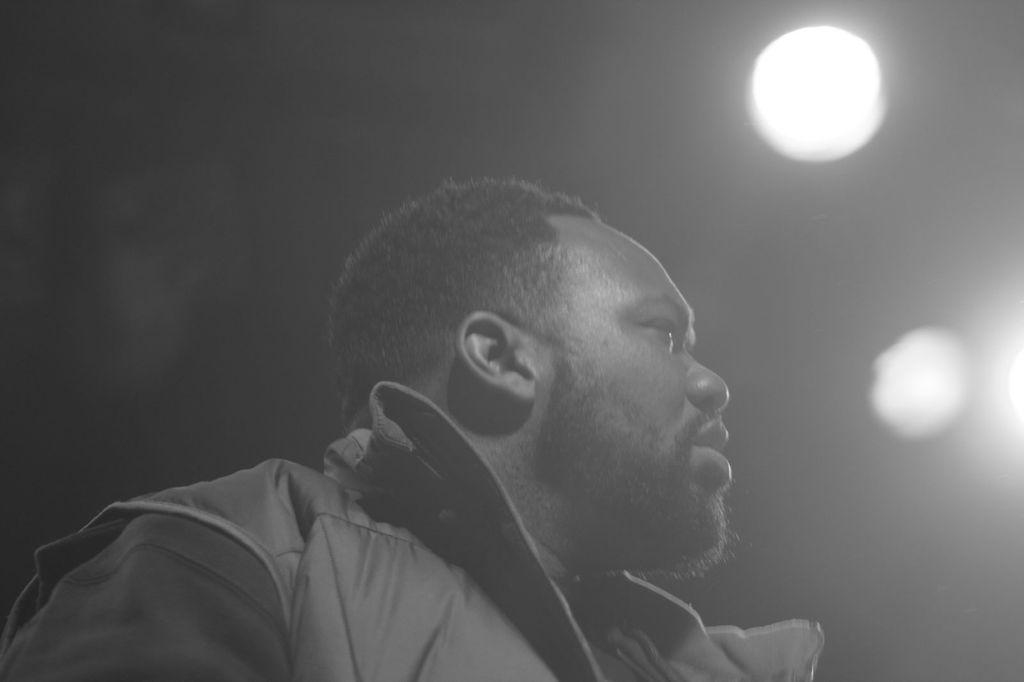What is the color scheme of the image? The image is black and white. Can you describe the main subject in the image? There is a person in the image. What can be seen in the background of the image? There are lights in the background of the image. How would you describe the overall lighting in the image? The image appears to be dark. What type of thread is being used by the person in the image? There is no thread visible in the image, as it is a black and white image of a person with lights in the background. 